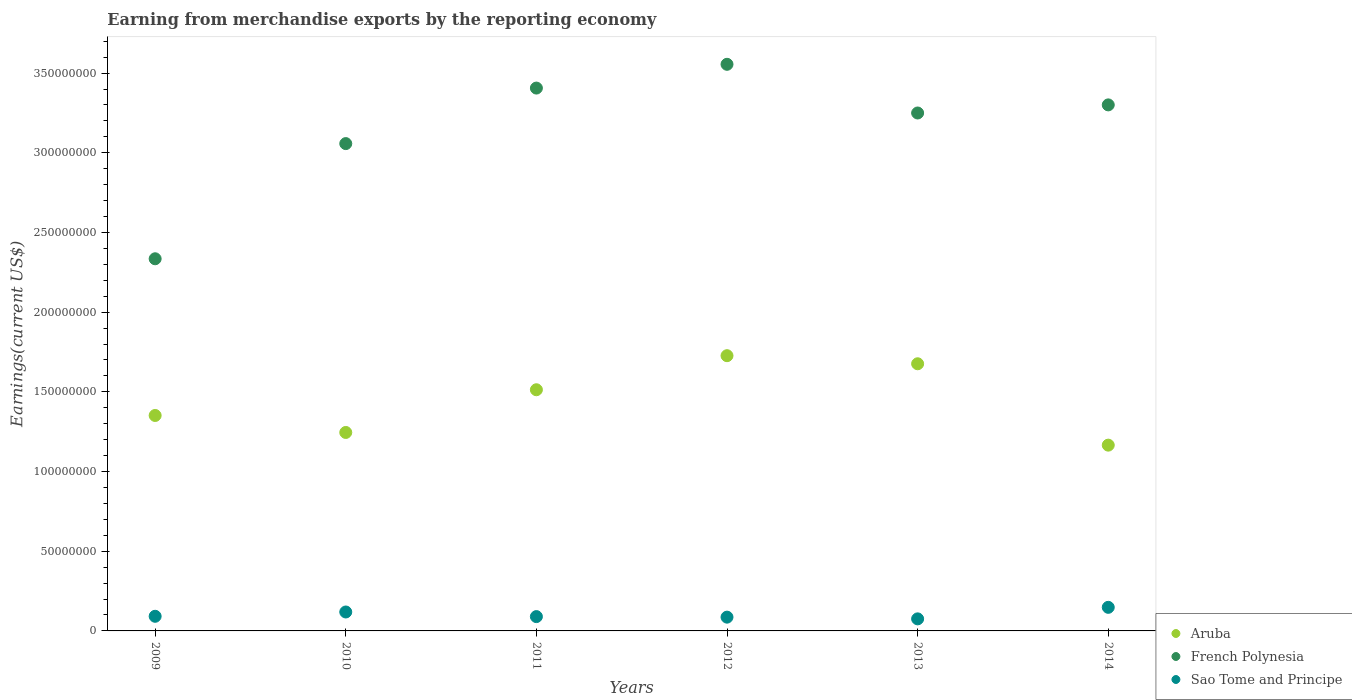What is the amount earned from merchandise exports in Sao Tome and Principe in 2013?
Keep it short and to the point. 7.57e+06. Across all years, what is the maximum amount earned from merchandise exports in French Polynesia?
Offer a terse response. 3.56e+08. Across all years, what is the minimum amount earned from merchandise exports in French Polynesia?
Offer a terse response. 2.34e+08. What is the total amount earned from merchandise exports in Sao Tome and Principe in the graph?
Your response must be concise. 6.11e+07. What is the difference between the amount earned from merchandise exports in Sao Tome and Principe in 2009 and that in 2014?
Provide a succinct answer. -5.62e+06. What is the difference between the amount earned from merchandise exports in Aruba in 2011 and the amount earned from merchandise exports in French Polynesia in 2014?
Offer a terse response. -1.79e+08. What is the average amount earned from merchandise exports in Sao Tome and Principe per year?
Ensure brevity in your answer.  1.02e+07. In the year 2010, what is the difference between the amount earned from merchandise exports in Aruba and amount earned from merchandise exports in French Polynesia?
Keep it short and to the point. -1.81e+08. What is the ratio of the amount earned from merchandise exports in Sao Tome and Principe in 2009 to that in 2013?
Your response must be concise. 1.21. Is the amount earned from merchandise exports in French Polynesia in 2009 less than that in 2011?
Make the answer very short. Yes. What is the difference between the highest and the second highest amount earned from merchandise exports in Aruba?
Keep it short and to the point. 5.07e+06. What is the difference between the highest and the lowest amount earned from merchandise exports in Sao Tome and Principe?
Provide a succinct answer. 7.23e+06. Is the sum of the amount earned from merchandise exports in Sao Tome and Principe in 2012 and 2013 greater than the maximum amount earned from merchandise exports in Aruba across all years?
Ensure brevity in your answer.  No. Is the amount earned from merchandise exports in Aruba strictly less than the amount earned from merchandise exports in Sao Tome and Principe over the years?
Offer a terse response. No. What is the difference between two consecutive major ticks on the Y-axis?
Ensure brevity in your answer.  5.00e+07. Are the values on the major ticks of Y-axis written in scientific E-notation?
Give a very brief answer. No. Does the graph contain any zero values?
Provide a short and direct response. No. Where does the legend appear in the graph?
Your response must be concise. Bottom right. How many legend labels are there?
Keep it short and to the point. 3. How are the legend labels stacked?
Your answer should be compact. Vertical. What is the title of the graph?
Offer a terse response. Earning from merchandise exports by the reporting economy. What is the label or title of the X-axis?
Your response must be concise. Years. What is the label or title of the Y-axis?
Give a very brief answer. Earnings(current US$). What is the Earnings(current US$) of Aruba in 2009?
Make the answer very short. 1.35e+08. What is the Earnings(current US$) in French Polynesia in 2009?
Keep it short and to the point. 2.34e+08. What is the Earnings(current US$) in Sao Tome and Principe in 2009?
Provide a succinct answer. 9.18e+06. What is the Earnings(current US$) of Aruba in 2010?
Make the answer very short. 1.25e+08. What is the Earnings(current US$) in French Polynesia in 2010?
Offer a very short reply. 3.06e+08. What is the Earnings(current US$) of Sao Tome and Principe in 2010?
Keep it short and to the point. 1.19e+07. What is the Earnings(current US$) in Aruba in 2011?
Offer a very short reply. 1.51e+08. What is the Earnings(current US$) in French Polynesia in 2011?
Your answer should be compact. 3.41e+08. What is the Earnings(current US$) in Sao Tome and Principe in 2011?
Your response must be concise. 8.98e+06. What is the Earnings(current US$) in Aruba in 2012?
Keep it short and to the point. 1.73e+08. What is the Earnings(current US$) in French Polynesia in 2012?
Make the answer very short. 3.56e+08. What is the Earnings(current US$) of Sao Tome and Principe in 2012?
Provide a succinct answer. 8.64e+06. What is the Earnings(current US$) in Aruba in 2013?
Give a very brief answer. 1.68e+08. What is the Earnings(current US$) of French Polynesia in 2013?
Offer a very short reply. 3.25e+08. What is the Earnings(current US$) of Sao Tome and Principe in 2013?
Provide a succinct answer. 7.57e+06. What is the Earnings(current US$) of Aruba in 2014?
Your response must be concise. 1.17e+08. What is the Earnings(current US$) of French Polynesia in 2014?
Offer a very short reply. 3.30e+08. What is the Earnings(current US$) of Sao Tome and Principe in 2014?
Make the answer very short. 1.48e+07. Across all years, what is the maximum Earnings(current US$) of Aruba?
Ensure brevity in your answer.  1.73e+08. Across all years, what is the maximum Earnings(current US$) in French Polynesia?
Your answer should be very brief. 3.56e+08. Across all years, what is the maximum Earnings(current US$) of Sao Tome and Principe?
Offer a terse response. 1.48e+07. Across all years, what is the minimum Earnings(current US$) in Aruba?
Your answer should be very brief. 1.17e+08. Across all years, what is the minimum Earnings(current US$) of French Polynesia?
Offer a terse response. 2.34e+08. Across all years, what is the minimum Earnings(current US$) in Sao Tome and Principe?
Your response must be concise. 7.57e+06. What is the total Earnings(current US$) of Aruba in the graph?
Provide a succinct answer. 8.68e+08. What is the total Earnings(current US$) of French Polynesia in the graph?
Make the answer very short. 1.89e+09. What is the total Earnings(current US$) in Sao Tome and Principe in the graph?
Offer a terse response. 6.11e+07. What is the difference between the Earnings(current US$) in Aruba in 2009 and that in 2010?
Ensure brevity in your answer.  1.07e+07. What is the difference between the Earnings(current US$) in French Polynesia in 2009 and that in 2010?
Keep it short and to the point. -7.23e+07. What is the difference between the Earnings(current US$) in Sao Tome and Principe in 2009 and that in 2010?
Your answer should be very brief. -2.70e+06. What is the difference between the Earnings(current US$) in Aruba in 2009 and that in 2011?
Provide a succinct answer. -1.61e+07. What is the difference between the Earnings(current US$) in French Polynesia in 2009 and that in 2011?
Offer a very short reply. -1.07e+08. What is the difference between the Earnings(current US$) of Sao Tome and Principe in 2009 and that in 2011?
Your answer should be compact. 1.99e+05. What is the difference between the Earnings(current US$) in Aruba in 2009 and that in 2012?
Your response must be concise. -3.75e+07. What is the difference between the Earnings(current US$) of French Polynesia in 2009 and that in 2012?
Your response must be concise. -1.22e+08. What is the difference between the Earnings(current US$) in Sao Tome and Principe in 2009 and that in 2012?
Provide a succinct answer. 5.38e+05. What is the difference between the Earnings(current US$) of Aruba in 2009 and that in 2013?
Offer a very short reply. -3.24e+07. What is the difference between the Earnings(current US$) of French Polynesia in 2009 and that in 2013?
Your response must be concise. -9.15e+07. What is the difference between the Earnings(current US$) in Sao Tome and Principe in 2009 and that in 2013?
Offer a terse response. 1.61e+06. What is the difference between the Earnings(current US$) in Aruba in 2009 and that in 2014?
Your response must be concise. 1.86e+07. What is the difference between the Earnings(current US$) in French Polynesia in 2009 and that in 2014?
Keep it short and to the point. -9.66e+07. What is the difference between the Earnings(current US$) of Sao Tome and Principe in 2009 and that in 2014?
Keep it short and to the point. -5.62e+06. What is the difference between the Earnings(current US$) in Aruba in 2010 and that in 2011?
Ensure brevity in your answer.  -2.68e+07. What is the difference between the Earnings(current US$) of French Polynesia in 2010 and that in 2011?
Make the answer very short. -3.48e+07. What is the difference between the Earnings(current US$) of Sao Tome and Principe in 2010 and that in 2011?
Keep it short and to the point. 2.90e+06. What is the difference between the Earnings(current US$) in Aruba in 2010 and that in 2012?
Offer a terse response. -4.82e+07. What is the difference between the Earnings(current US$) of French Polynesia in 2010 and that in 2012?
Your response must be concise. -4.98e+07. What is the difference between the Earnings(current US$) of Sao Tome and Principe in 2010 and that in 2012?
Your answer should be very brief. 3.24e+06. What is the difference between the Earnings(current US$) in Aruba in 2010 and that in 2013?
Give a very brief answer. -4.31e+07. What is the difference between the Earnings(current US$) of French Polynesia in 2010 and that in 2013?
Ensure brevity in your answer.  -1.92e+07. What is the difference between the Earnings(current US$) in Sao Tome and Principe in 2010 and that in 2013?
Provide a succinct answer. 4.31e+06. What is the difference between the Earnings(current US$) in Aruba in 2010 and that in 2014?
Your response must be concise. 7.96e+06. What is the difference between the Earnings(current US$) of French Polynesia in 2010 and that in 2014?
Ensure brevity in your answer.  -2.43e+07. What is the difference between the Earnings(current US$) of Sao Tome and Principe in 2010 and that in 2014?
Ensure brevity in your answer.  -2.92e+06. What is the difference between the Earnings(current US$) of Aruba in 2011 and that in 2012?
Your answer should be compact. -2.14e+07. What is the difference between the Earnings(current US$) of French Polynesia in 2011 and that in 2012?
Your answer should be very brief. -1.49e+07. What is the difference between the Earnings(current US$) of Sao Tome and Principe in 2011 and that in 2012?
Give a very brief answer. 3.39e+05. What is the difference between the Earnings(current US$) of Aruba in 2011 and that in 2013?
Your answer should be very brief. -1.63e+07. What is the difference between the Earnings(current US$) in French Polynesia in 2011 and that in 2013?
Your response must be concise. 1.56e+07. What is the difference between the Earnings(current US$) in Sao Tome and Principe in 2011 and that in 2013?
Give a very brief answer. 1.41e+06. What is the difference between the Earnings(current US$) of Aruba in 2011 and that in 2014?
Offer a terse response. 3.48e+07. What is the difference between the Earnings(current US$) of French Polynesia in 2011 and that in 2014?
Offer a very short reply. 1.05e+07. What is the difference between the Earnings(current US$) of Sao Tome and Principe in 2011 and that in 2014?
Your response must be concise. -5.82e+06. What is the difference between the Earnings(current US$) in Aruba in 2012 and that in 2013?
Make the answer very short. 5.07e+06. What is the difference between the Earnings(current US$) of French Polynesia in 2012 and that in 2013?
Your answer should be very brief. 3.06e+07. What is the difference between the Earnings(current US$) in Sao Tome and Principe in 2012 and that in 2013?
Keep it short and to the point. 1.08e+06. What is the difference between the Earnings(current US$) of Aruba in 2012 and that in 2014?
Your answer should be compact. 5.61e+07. What is the difference between the Earnings(current US$) of French Polynesia in 2012 and that in 2014?
Provide a succinct answer. 2.55e+07. What is the difference between the Earnings(current US$) of Sao Tome and Principe in 2012 and that in 2014?
Ensure brevity in your answer.  -6.16e+06. What is the difference between the Earnings(current US$) of Aruba in 2013 and that in 2014?
Keep it short and to the point. 5.11e+07. What is the difference between the Earnings(current US$) in French Polynesia in 2013 and that in 2014?
Your response must be concise. -5.09e+06. What is the difference between the Earnings(current US$) in Sao Tome and Principe in 2013 and that in 2014?
Make the answer very short. -7.23e+06. What is the difference between the Earnings(current US$) in Aruba in 2009 and the Earnings(current US$) in French Polynesia in 2010?
Make the answer very short. -1.71e+08. What is the difference between the Earnings(current US$) in Aruba in 2009 and the Earnings(current US$) in Sao Tome and Principe in 2010?
Your answer should be compact. 1.23e+08. What is the difference between the Earnings(current US$) in French Polynesia in 2009 and the Earnings(current US$) in Sao Tome and Principe in 2010?
Your answer should be compact. 2.22e+08. What is the difference between the Earnings(current US$) in Aruba in 2009 and the Earnings(current US$) in French Polynesia in 2011?
Your answer should be compact. -2.05e+08. What is the difference between the Earnings(current US$) in Aruba in 2009 and the Earnings(current US$) in Sao Tome and Principe in 2011?
Ensure brevity in your answer.  1.26e+08. What is the difference between the Earnings(current US$) of French Polynesia in 2009 and the Earnings(current US$) of Sao Tome and Principe in 2011?
Give a very brief answer. 2.25e+08. What is the difference between the Earnings(current US$) in Aruba in 2009 and the Earnings(current US$) in French Polynesia in 2012?
Ensure brevity in your answer.  -2.20e+08. What is the difference between the Earnings(current US$) in Aruba in 2009 and the Earnings(current US$) in Sao Tome and Principe in 2012?
Your answer should be compact. 1.27e+08. What is the difference between the Earnings(current US$) in French Polynesia in 2009 and the Earnings(current US$) in Sao Tome and Principe in 2012?
Your answer should be compact. 2.25e+08. What is the difference between the Earnings(current US$) in Aruba in 2009 and the Earnings(current US$) in French Polynesia in 2013?
Your answer should be very brief. -1.90e+08. What is the difference between the Earnings(current US$) of Aruba in 2009 and the Earnings(current US$) of Sao Tome and Principe in 2013?
Keep it short and to the point. 1.28e+08. What is the difference between the Earnings(current US$) in French Polynesia in 2009 and the Earnings(current US$) in Sao Tome and Principe in 2013?
Your answer should be very brief. 2.26e+08. What is the difference between the Earnings(current US$) in Aruba in 2009 and the Earnings(current US$) in French Polynesia in 2014?
Your answer should be compact. -1.95e+08. What is the difference between the Earnings(current US$) of Aruba in 2009 and the Earnings(current US$) of Sao Tome and Principe in 2014?
Offer a very short reply. 1.20e+08. What is the difference between the Earnings(current US$) of French Polynesia in 2009 and the Earnings(current US$) of Sao Tome and Principe in 2014?
Provide a short and direct response. 2.19e+08. What is the difference between the Earnings(current US$) in Aruba in 2010 and the Earnings(current US$) in French Polynesia in 2011?
Your answer should be very brief. -2.16e+08. What is the difference between the Earnings(current US$) in Aruba in 2010 and the Earnings(current US$) in Sao Tome and Principe in 2011?
Ensure brevity in your answer.  1.16e+08. What is the difference between the Earnings(current US$) of French Polynesia in 2010 and the Earnings(current US$) of Sao Tome and Principe in 2011?
Ensure brevity in your answer.  2.97e+08. What is the difference between the Earnings(current US$) in Aruba in 2010 and the Earnings(current US$) in French Polynesia in 2012?
Make the answer very short. -2.31e+08. What is the difference between the Earnings(current US$) of Aruba in 2010 and the Earnings(current US$) of Sao Tome and Principe in 2012?
Offer a terse response. 1.16e+08. What is the difference between the Earnings(current US$) in French Polynesia in 2010 and the Earnings(current US$) in Sao Tome and Principe in 2012?
Your answer should be very brief. 2.97e+08. What is the difference between the Earnings(current US$) of Aruba in 2010 and the Earnings(current US$) of French Polynesia in 2013?
Offer a terse response. -2.00e+08. What is the difference between the Earnings(current US$) of Aruba in 2010 and the Earnings(current US$) of Sao Tome and Principe in 2013?
Your answer should be very brief. 1.17e+08. What is the difference between the Earnings(current US$) of French Polynesia in 2010 and the Earnings(current US$) of Sao Tome and Principe in 2013?
Your response must be concise. 2.98e+08. What is the difference between the Earnings(current US$) in Aruba in 2010 and the Earnings(current US$) in French Polynesia in 2014?
Offer a very short reply. -2.06e+08. What is the difference between the Earnings(current US$) in Aruba in 2010 and the Earnings(current US$) in Sao Tome and Principe in 2014?
Keep it short and to the point. 1.10e+08. What is the difference between the Earnings(current US$) of French Polynesia in 2010 and the Earnings(current US$) of Sao Tome and Principe in 2014?
Make the answer very short. 2.91e+08. What is the difference between the Earnings(current US$) of Aruba in 2011 and the Earnings(current US$) of French Polynesia in 2012?
Your answer should be very brief. -2.04e+08. What is the difference between the Earnings(current US$) in Aruba in 2011 and the Earnings(current US$) in Sao Tome and Principe in 2012?
Your answer should be compact. 1.43e+08. What is the difference between the Earnings(current US$) in French Polynesia in 2011 and the Earnings(current US$) in Sao Tome and Principe in 2012?
Make the answer very short. 3.32e+08. What is the difference between the Earnings(current US$) of Aruba in 2011 and the Earnings(current US$) of French Polynesia in 2013?
Give a very brief answer. -1.74e+08. What is the difference between the Earnings(current US$) of Aruba in 2011 and the Earnings(current US$) of Sao Tome and Principe in 2013?
Your answer should be compact. 1.44e+08. What is the difference between the Earnings(current US$) in French Polynesia in 2011 and the Earnings(current US$) in Sao Tome and Principe in 2013?
Your answer should be very brief. 3.33e+08. What is the difference between the Earnings(current US$) in Aruba in 2011 and the Earnings(current US$) in French Polynesia in 2014?
Your response must be concise. -1.79e+08. What is the difference between the Earnings(current US$) of Aruba in 2011 and the Earnings(current US$) of Sao Tome and Principe in 2014?
Your response must be concise. 1.37e+08. What is the difference between the Earnings(current US$) in French Polynesia in 2011 and the Earnings(current US$) in Sao Tome and Principe in 2014?
Provide a succinct answer. 3.26e+08. What is the difference between the Earnings(current US$) of Aruba in 2012 and the Earnings(current US$) of French Polynesia in 2013?
Your response must be concise. -1.52e+08. What is the difference between the Earnings(current US$) in Aruba in 2012 and the Earnings(current US$) in Sao Tome and Principe in 2013?
Provide a succinct answer. 1.65e+08. What is the difference between the Earnings(current US$) in French Polynesia in 2012 and the Earnings(current US$) in Sao Tome and Principe in 2013?
Your answer should be very brief. 3.48e+08. What is the difference between the Earnings(current US$) in Aruba in 2012 and the Earnings(current US$) in French Polynesia in 2014?
Your answer should be very brief. -1.57e+08. What is the difference between the Earnings(current US$) of Aruba in 2012 and the Earnings(current US$) of Sao Tome and Principe in 2014?
Your answer should be very brief. 1.58e+08. What is the difference between the Earnings(current US$) in French Polynesia in 2012 and the Earnings(current US$) in Sao Tome and Principe in 2014?
Your response must be concise. 3.41e+08. What is the difference between the Earnings(current US$) in Aruba in 2013 and the Earnings(current US$) in French Polynesia in 2014?
Your response must be concise. -1.62e+08. What is the difference between the Earnings(current US$) in Aruba in 2013 and the Earnings(current US$) in Sao Tome and Principe in 2014?
Give a very brief answer. 1.53e+08. What is the difference between the Earnings(current US$) of French Polynesia in 2013 and the Earnings(current US$) of Sao Tome and Principe in 2014?
Offer a terse response. 3.10e+08. What is the average Earnings(current US$) in Aruba per year?
Keep it short and to the point. 1.45e+08. What is the average Earnings(current US$) in French Polynesia per year?
Ensure brevity in your answer.  3.15e+08. What is the average Earnings(current US$) in Sao Tome and Principe per year?
Provide a succinct answer. 1.02e+07. In the year 2009, what is the difference between the Earnings(current US$) of Aruba and Earnings(current US$) of French Polynesia?
Give a very brief answer. -9.83e+07. In the year 2009, what is the difference between the Earnings(current US$) of Aruba and Earnings(current US$) of Sao Tome and Principe?
Ensure brevity in your answer.  1.26e+08. In the year 2009, what is the difference between the Earnings(current US$) of French Polynesia and Earnings(current US$) of Sao Tome and Principe?
Keep it short and to the point. 2.24e+08. In the year 2010, what is the difference between the Earnings(current US$) in Aruba and Earnings(current US$) in French Polynesia?
Make the answer very short. -1.81e+08. In the year 2010, what is the difference between the Earnings(current US$) of Aruba and Earnings(current US$) of Sao Tome and Principe?
Your response must be concise. 1.13e+08. In the year 2010, what is the difference between the Earnings(current US$) in French Polynesia and Earnings(current US$) in Sao Tome and Principe?
Offer a very short reply. 2.94e+08. In the year 2011, what is the difference between the Earnings(current US$) of Aruba and Earnings(current US$) of French Polynesia?
Your answer should be very brief. -1.89e+08. In the year 2011, what is the difference between the Earnings(current US$) of Aruba and Earnings(current US$) of Sao Tome and Principe?
Your response must be concise. 1.42e+08. In the year 2011, what is the difference between the Earnings(current US$) in French Polynesia and Earnings(current US$) in Sao Tome and Principe?
Your answer should be very brief. 3.32e+08. In the year 2012, what is the difference between the Earnings(current US$) in Aruba and Earnings(current US$) in French Polynesia?
Provide a succinct answer. -1.83e+08. In the year 2012, what is the difference between the Earnings(current US$) in Aruba and Earnings(current US$) in Sao Tome and Principe?
Your answer should be very brief. 1.64e+08. In the year 2012, what is the difference between the Earnings(current US$) in French Polynesia and Earnings(current US$) in Sao Tome and Principe?
Offer a terse response. 3.47e+08. In the year 2013, what is the difference between the Earnings(current US$) in Aruba and Earnings(current US$) in French Polynesia?
Offer a very short reply. -1.57e+08. In the year 2013, what is the difference between the Earnings(current US$) in Aruba and Earnings(current US$) in Sao Tome and Principe?
Your answer should be very brief. 1.60e+08. In the year 2013, what is the difference between the Earnings(current US$) of French Polynesia and Earnings(current US$) of Sao Tome and Principe?
Make the answer very short. 3.17e+08. In the year 2014, what is the difference between the Earnings(current US$) in Aruba and Earnings(current US$) in French Polynesia?
Make the answer very short. -2.13e+08. In the year 2014, what is the difference between the Earnings(current US$) in Aruba and Earnings(current US$) in Sao Tome and Principe?
Ensure brevity in your answer.  1.02e+08. In the year 2014, what is the difference between the Earnings(current US$) in French Polynesia and Earnings(current US$) in Sao Tome and Principe?
Ensure brevity in your answer.  3.15e+08. What is the ratio of the Earnings(current US$) of Aruba in 2009 to that in 2010?
Your response must be concise. 1.09. What is the ratio of the Earnings(current US$) of French Polynesia in 2009 to that in 2010?
Keep it short and to the point. 0.76. What is the ratio of the Earnings(current US$) of Sao Tome and Principe in 2009 to that in 2010?
Make the answer very short. 0.77. What is the ratio of the Earnings(current US$) in Aruba in 2009 to that in 2011?
Provide a succinct answer. 0.89. What is the ratio of the Earnings(current US$) in French Polynesia in 2009 to that in 2011?
Your answer should be very brief. 0.69. What is the ratio of the Earnings(current US$) of Sao Tome and Principe in 2009 to that in 2011?
Your answer should be compact. 1.02. What is the ratio of the Earnings(current US$) in Aruba in 2009 to that in 2012?
Give a very brief answer. 0.78. What is the ratio of the Earnings(current US$) of French Polynesia in 2009 to that in 2012?
Your answer should be very brief. 0.66. What is the ratio of the Earnings(current US$) of Sao Tome and Principe in 2009 to that in 2012?
Keep it short and to the point. 1.06. What is the ratio of the Earnings(current US$) of Aruba in 2009 to that in 2013?
Offer a terse response. 0.81. What is the ratio of the Earnings(current US$) in French Polynesia in 2009 to that in 2013?
Your answer should be very brief. 0.72. What is the ratio of the Earnings(current US$) in Sao Tome and Principe in 2009 to that in 2013?
Provide a short and direct response. 1.21. What is the ratio of the Earnings(current US$) in Aruba in 2009 to that in 2014?
Offer a terse response. 1.16. What is the ratio of the Earnings(current US$) in French Polynesia in 2009 to that in 2014?
Provide a short and direct response. 0.71. What is the ratio of the Earnings(current US$) of Sao Tome and Principe in 2009 to that in 2014?
Make the answer very short. 0.62. What is the ratio of the Earnings(current US$) of Aruba in 2010 to that in 2011?
Offer a terse response. 0.82. What is the ratio of the Earnings(current US$) in French Polynesia in 2010 to that in 2011?
Provide a succinct answer. 0.9. What is the ratio of the Earnings(current US$) of Sao Tome and Principe in 2010 to that in 2011?
Provide a succinct answer. 1.32. What is the ratio of the Earnings(current US$) in Aruba in 2010 to that in 2012?
Provide a succinct answer. 0.72. What is the ratio of the Earnings(current US$) in French Polynesia in 2010 to that in 2012?
Make the answer very short. 0.86. What is the ratio of the Earnings(current US$) of Sao Tome and Principe in 2010 to that in 2012?
Your answer should be compact. 1.37. What is the ratio of the Earnings(current US$) in Aruba in 2010 to that in 2013?
Offer a terse response. 0.74. What is the ratio of the Earnings(current US$) in French Polynesia in 2010 to that in 2013?
Offer a terse response. 0.94. What is the ratio of the Earnings(current US$) of Sao Tome and Principe in 2010 to that in 2013?
Your answer should be compact. 1.57. What is the ratio of the Earnings(current US$) in Aruba in 2010 to that in 2014?
Ensure brevity in your answer.  1.07. What is the ratio of the Earnings(current US$) of French Polynesia in 2010 to that in 2014?
Your answer should be very brief. 0.93. What is the ratio of the Earnings(current US$) in Sao Tome and Principe in 2010 to that in 2014?
Give a very brief answer. 0.8. What is the ratio of the Earnings(current US$) of Aruba in 2011 to that in 2012?
Offer a very short reply. 0.88. What is the ratio of the Earnings(current US$) in French Polynesia in 2011 to that in 2012?
Keep it short and to the point. 0.96. What is the ratio of the Earnings(current US$) in Sao Tome and Principe in 2011 to that in 2012?
Offer a terse response. 1.04. What is the ratio of the Earnings(current US$) of Aruba in 2011 to that in 2013?
Your answer should be compact. 0.9. What is the ratio of the Earnings(current US$) of French Polynesia in 2011 to that in 2013?
Your answer should be compact. 1.05. What is the ratio of the Earnings(current US$) of Sao Tome and Principe in 2011 to that in 2013?
Your response must be concise. 1.19. What is the ratio of the Earnings(current US$) in Aruba in 2011 to that in 2014?
Provide a short and direct response. 1.3. What is the ratio of the Earnings(current US$) of French Polynesia in 2011 to that in 2014?
Give a very brief answer. 1.03. What is the ratio of the Earnings(current US$) of Sao Tome and Principe in 2011 to that in 2014?
Provide a short and direct response. 0.61. What is the ratio of the Earnings(current US$) in Aruba in 2012 to that in 2013?
Make the answer very short. 1.03. What is the ratio of the Earnings(current US$) in French Polynesia in 2012 to that in 2013?
Make the answer very short. 1.09. What is the ratio of the Earnings(current US$) in Sao Tome and Principe in 2012 to that in 2013?
Offer a terse response. 1.14. What is the ratio of the Earnings(current US$) of Aruba in 2012 to that in 2014?
Make the answer very short. 1.48. What is the ratio of the Earnings(current US$) of French Polynesia in 2012 to that in 2014?
Your answer should be compact. 1.08. What is the ratio of the Earnings(current US$) of Sao Tome and Principe in 2012 to that in 2014?
Your response must be concise. 0.58. What is the ratio of the Earnings(current US$) of Aruba in 2013 to that in 2014?
Provide a short and direct response. 1.44. What is the ratio of the Earnings(current US$) in French Polynesia in 2013 to that in 2014?
Ensure brevity in your answer.  0.98. What is the ratio of the Earnings(current US$) in Sao Tome and Principe in 2013 to that in 2014?
Your answer should be compact. 0.51. What is the difference between the highest and the second highest Earnings(current US$) of Aruba?
Offer a very short reply. 5.07e+06. What is the difference between the highest and the second highest Earnings(current US$) of French Polynesia?
Your response must be concise. 1.49e+07. What is the difference between the highest and the second highest Earnings(current US$) of Sao Tome and Principe?
Ensure brevity in your answer.  2.92e+06. What is the difference between the highest and the lowest Earnings(current US$) in Aruba?
Your response must be concise. 5.61e+07. What is the difference between the highest and the lowest Earnings(current US$) of French Polynesia?
Your response must be concise. 1.22e+08. What is the difference between the highest and the lowest Earnings(current US$) in Sao Tome and Principe?
Your answer should be very brief. 7.23e+06. 